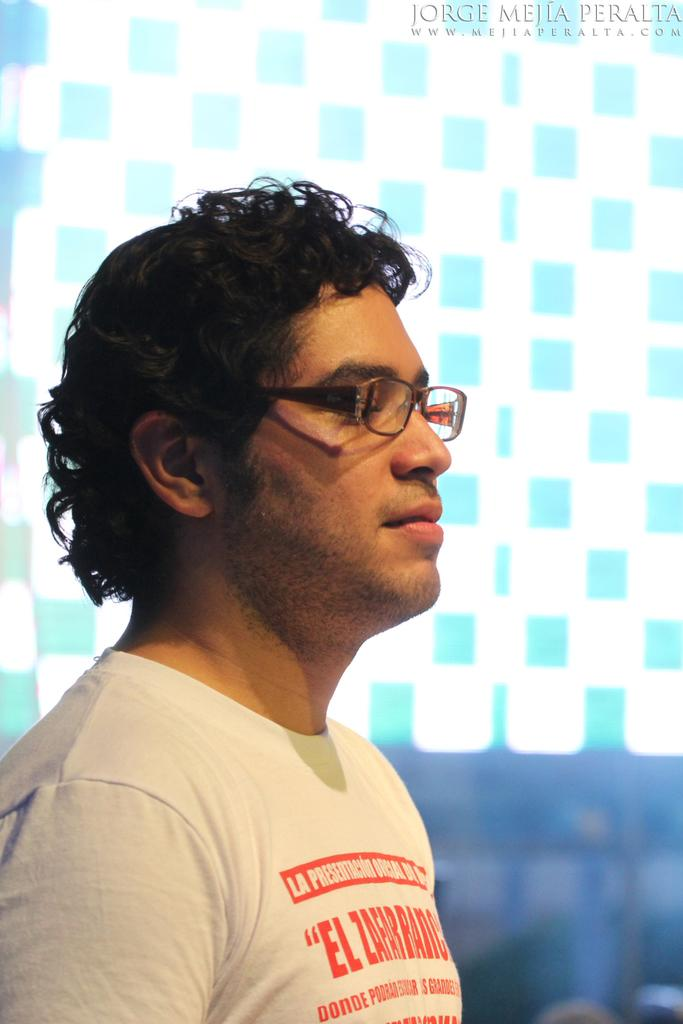What is the main subject of the image? There is a person standing in the image. Can you describe the person's appearance? The person is wearing spectacles and a t-shirt. What type of education does the doll in the image have? There is no doll present in the image, so it is not possible to determine the doll's education. 